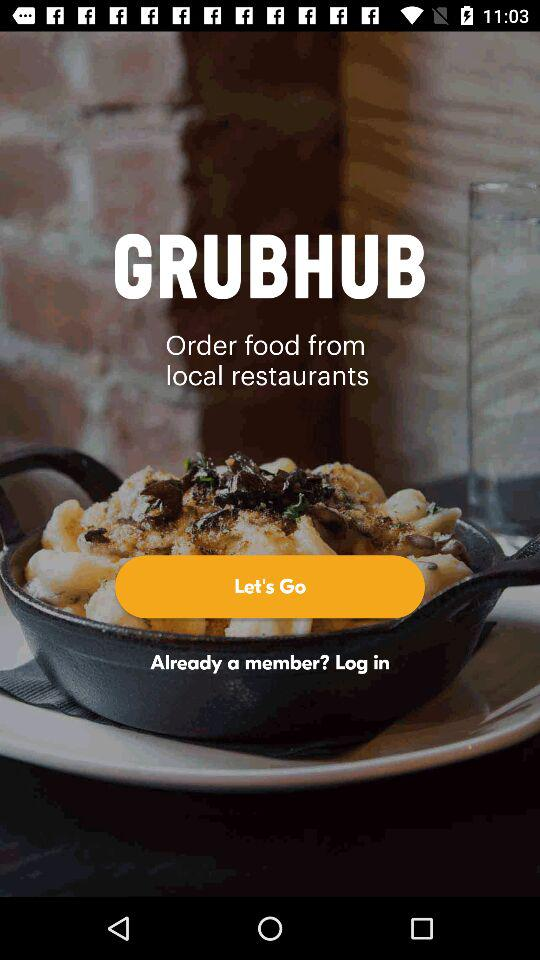What is the application name? The application name is "GRUBHUB". 